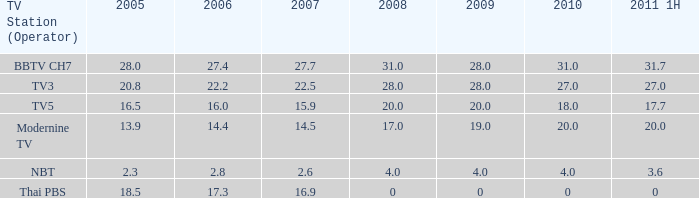What is the average 2007 value for a 2006 of 2.8 and 2009 under 20? 2.6. 